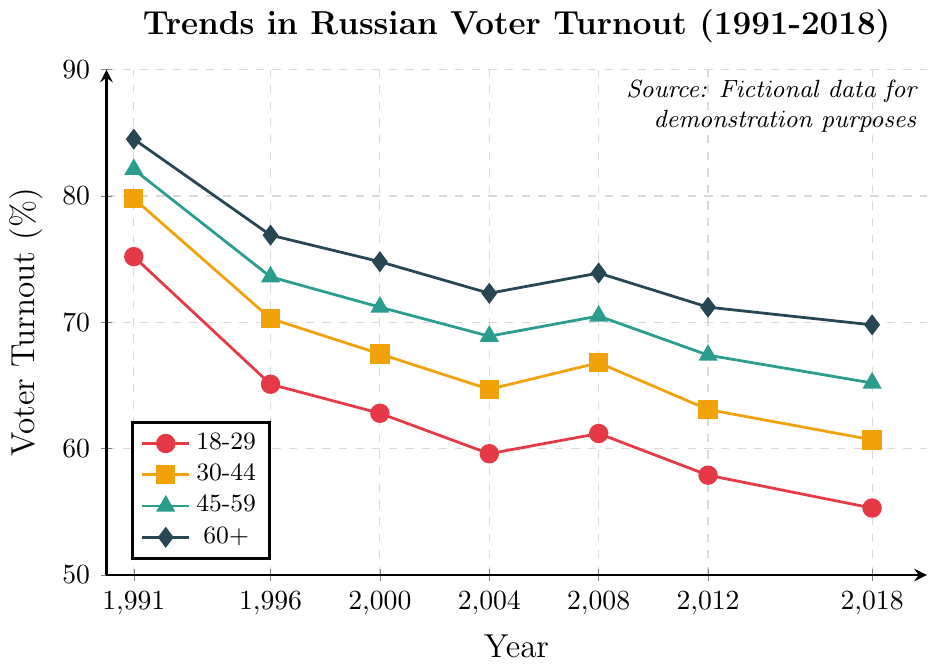what's the average voter turnout for the 18-29 age group across all years? To calculate the average turnout for the 18-29 age group, sum up the turnout percentages for each year (75.2 + 65.1 + 62.8 + 59.6 + 61.2 + 57.9 + 55.3) and then divide by the number of years (7). The total sum is 437.1, so the average is 437.1 / 7 = 62.44
Answer: 62.44 Which age group had the highest voter turnout in 1991? In 1991, the voter turnout percentages are as follows: 18-29 (75.2), 30-44 (79.8), 45-59 (82.1), 60+ (84.5). The highest value among these is 84.5 for the 60+ age group.
Answer: 60+ What is the difference in voter turnout between the 45-59 and 18-29 age groups in 1996? The voter turnout in 1996 is 73.6 for the 45-59 age group and 65.1 for the 18-29 age group. The difference is 73.6 - 65.1 = 8.5.
Answer: 8.5 Which age group showed the smallest decline in voter turnout from 1991 to 2018? For each age group, subtract the voter turnout in 2018 from that in 1991: 
18-29: 75.2 - 55.3 = 19.9,
30-44: 79.8 - 60.7 = 19.1,
45-59: 82.1 - 65.2 = 16.9,
60+: 84.5 - 69.8 = 14.7.
The smallest decline is observed in the 60+ age group.
Answer: 60+ By how much did voter turnout decrease for the 30-44 age group from 2000 to 2018? The voter turnout for the 30-44 age group in 2000 was 67.5 and in 2018 it was 60.7. The decrease is 67.5 - 60.7 = 6.8.
Answer: 6.8 Which age group had the most consistent voter turnout trend from 1991 to 2018 based on visual inspection? Visually, the 60+ age group shows the smallest fluctuations and a more gradual decline compared to the other age groups, indicating a more consistent trend.
Answer: 60+ In which year did the 18-29 age group experience the largest drop in voter turnout compared to the previous election? Checking each election year for the 18-29 age group:
1991 to 1996: 75.2 - 65.1 = 10.1,
1996 to 2000: 65.1 - 62.8 = 2.3,
2000 to 2004: 62.8 - 59.6 = 3.2,
2004 to 2008: 59.6 - 61.2 = -1.6 (increase),
2008 to 2012: 61.2 - 57.9 = 3.3,
2012 to 2018: 57.9 - 55.3 = 2.6.
The largest drop is from 1991 to 1996, which is 10.1.
Answer: 1996 Did any age group show an increase in voter turnout between any two consecutive elections? The 18-29 age group saw an increase in turnout from 2004 to 2008 (59.6 to 61.2), and the 30-44 age group also saw an increase from 2004 to 2008 (64.7 to 66.8).
Answer: Yes Which two consecutive election years show the smallest change in voter turnout for the 45-59 age group? Checking consecutive election years for the 45-59 age group:
1991-1996: 82.1 to 73.6, change = 8.5
1996-2000: 73.6 to 71.2, change = 2.4
2000-2004: 71.2 to 68.9, change = 2.3
2004-2008: 68.9 to 70.5, change = -1.6
2008-2012: 70.5 to 67.4, change = 3.1
2012-2018: 67.4 to 65.2, change = 2.2
The smallest change is from 2012 to 2018 with a change of 2.2.
Answer: 2012-2018 Which age group had a voter turnout of approximately 70% in 2018? In 2018, the 60+ age group had a voter turnout of 69.8%, which is approximately 70%.
Answer: 60+ 